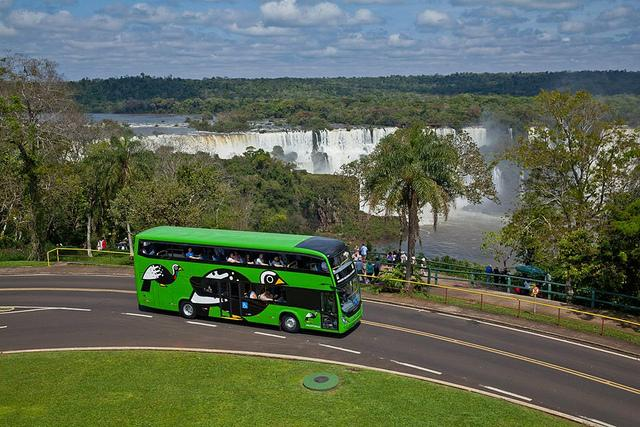Where are the people on the bus going? Please explain your reasoning. sightseeing. The bus shown is for tourists. 